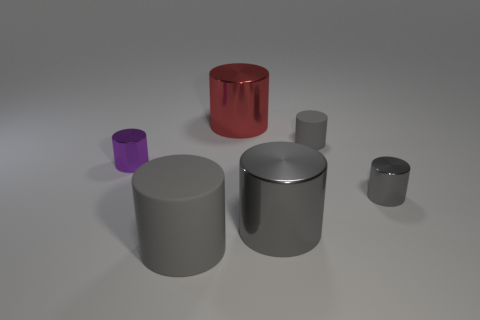How many gray cylinders must be subtracted to get 1 gray cylinders? 3 Subtract all cyan cubes. How many gray cylinders are left? 4 Subtract all purple cylinders. How many cylinders are left? 5 Subtract 2 cylinders. How many cylinders are left? 4 Subtract all small purple metal cylinders. How many cylinders are left? 5 Subtract all brown cylinders. Subtract all green spheres. How many cylinders are left? 6 Add 1 purple metal things. How many objects exist? 7 Subtract 0 green cubes. How many objects are left? 6 Subtract all purple things. Subtract all big gray shiny cylinders. How many objects are left? 4 Add 5 gray metal objects. How many gray metal objects are left? 7 